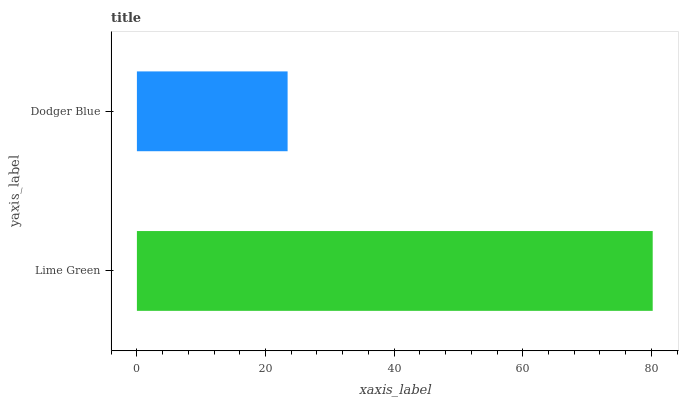Is Dodger Blue the minimum?
Answer yes or no. Yes. Is Lime Green the maximum?
Answer yes or no. Yes. Is Dodger Blue the maximum?
Answer yes or no. No. Is Lime Green greater than Dodger Blue?
Answer yes or no. Yes. Is Dodger Blue less than Lime Green?
Answer yes or no. Yes. Is Dodger Blue greater than Lime Green?
Answer yes or no. No. Is Lime Green less than Dodger Blue?
Answer yes or no. No. Is Lime Green the high median?
Answer yes or no. Yes. Is Dodger Blue the low median?
Answer yes or no. Yes. Is Dodger Blue the high median?
Answer yes or no. No. Is Lime Green the low median?
Answer yes or no. No. 